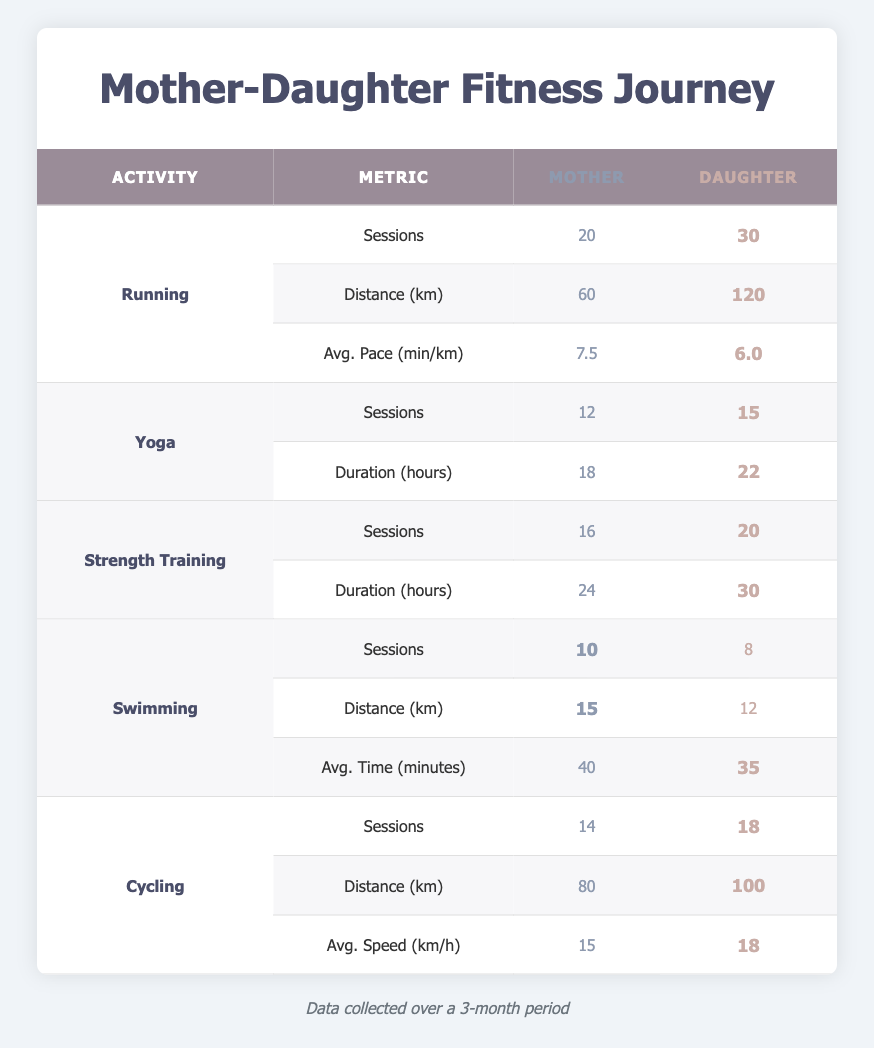What is the total number of running sessions completed by both mother and daughter? The mother completed 20 sessions and the daughter completed 30 sessions. Adding these together (20 + 30) gives a total of 50 running sessions.
Answer: 50 How much distance did the mother run in kilometers? The table shows that the mother ran a total distance of 60 kilometers over 20 sessions.
Answer: 60 km Did the daughter have a faster average pace than the mother while running? The daughter's average pace is 6.0 minutes per kilometer, while the mother's average pace is 7.5 minutes per kilometer. Since 6.0 is less than 7.5, the daughter did indeed have a faster average pace.
Answer: Yes What is the difference in the number of yoga sessions completed by mother and daughter? The mother completed 12 yoga sessions, while the daughter completed 15 sessions. The difference can be calculated by subtracting the mother's sessions from the daughter's (15 - 12), which equals 3 sessions.
Answer: 3 sessions How would you compare the average speed during cycling of both mother and daughter? The mother maintained an average speed of 15 km/h during her cycling sessions, whereas the daughter had a faster average speed of 18 km/h. Therefore, the daughter cycled at a higher average speed than the mother.
Answer: Daughter had a higher average speed What was the total duration of strength training sessions for mother and daughter? The mother completed 24 hours of strength training while the daughter completed 30 hours. By adding both durations together (24 + 30), we find that the total duration of strength training sessions for both is 54 hours.
Answer: 54 hours How many more sessions did the daughter complete in swimming compared to the mother? The mother had 10 swimming sessions, while the daughter had 8 sessions. The daughter actually completed fewer sessions, so the difference (10 - 8) shows that the mother had 2 more sessions than the daughter.
Answer: 2 more sessions for mother What is the total distance traveled by both mother and daughter in cycling? The mother cycled 80 kilometers, and the daughter cycled 100 kilometers. To find the total distance, we sum these distances (80 + 100), resulting in a total of 180 kilometers traveled by both during cycling.
Answer: 180 km Which activity did the mother have more sessions in: swimming or yoga? The mother had 10 swimming sessions and 12 yoga sessions. Comparing these numbers indicates that she had more yoga sessions (12) than swimming sessions (10).
Answer: More yoga sessions 